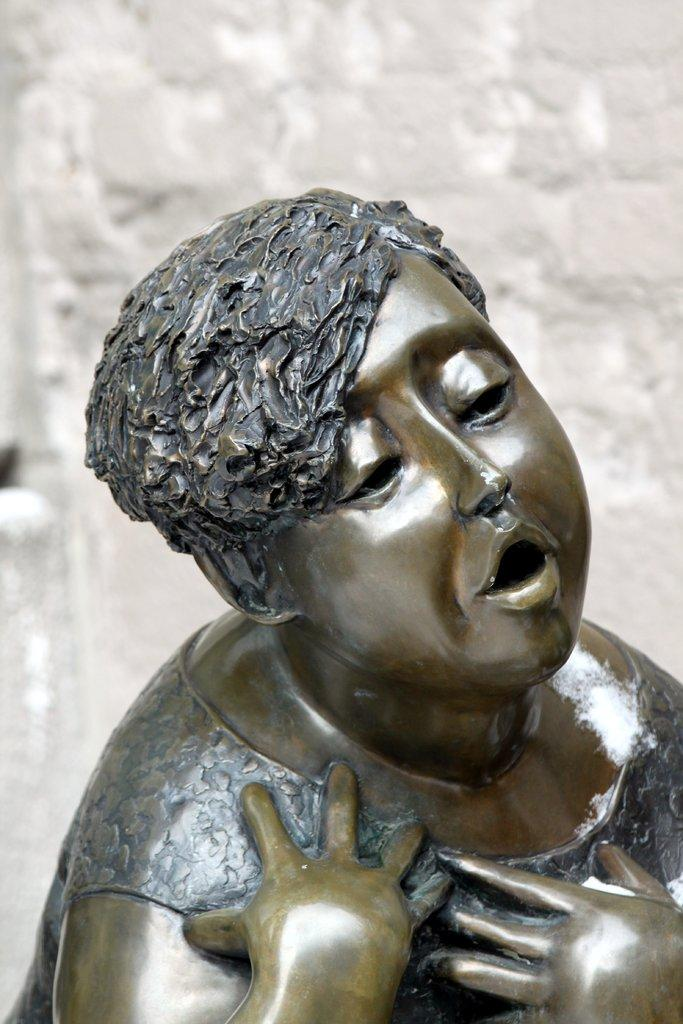What is the main subject of the image? There is a statue of a boy in the image. What can be seen in the background of the image? There is a wall in the background of the image. What is the color of the wall? The wall is white in color. What is the price of the account on the canvas in the image? There is no account or canvas present in the image; it features a statue of a boy and a white wall in the background. 